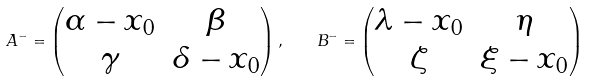Convert formula to latex. <formula><loc_0><loc_0><loc_500><loc_500>A ^ { - } = \begin{pmatrix} \alpha - x _ { 0 } & \beta \\ \gamma & \delta - x _ { 0 } \end{pmatrix} , \quad B ^ { - } = \begin{pmatrix} \lambda - x _ { 0 } & \eta \\ \zeta & \xi - x _ { 0 } \end{pmatrix}</formula> 